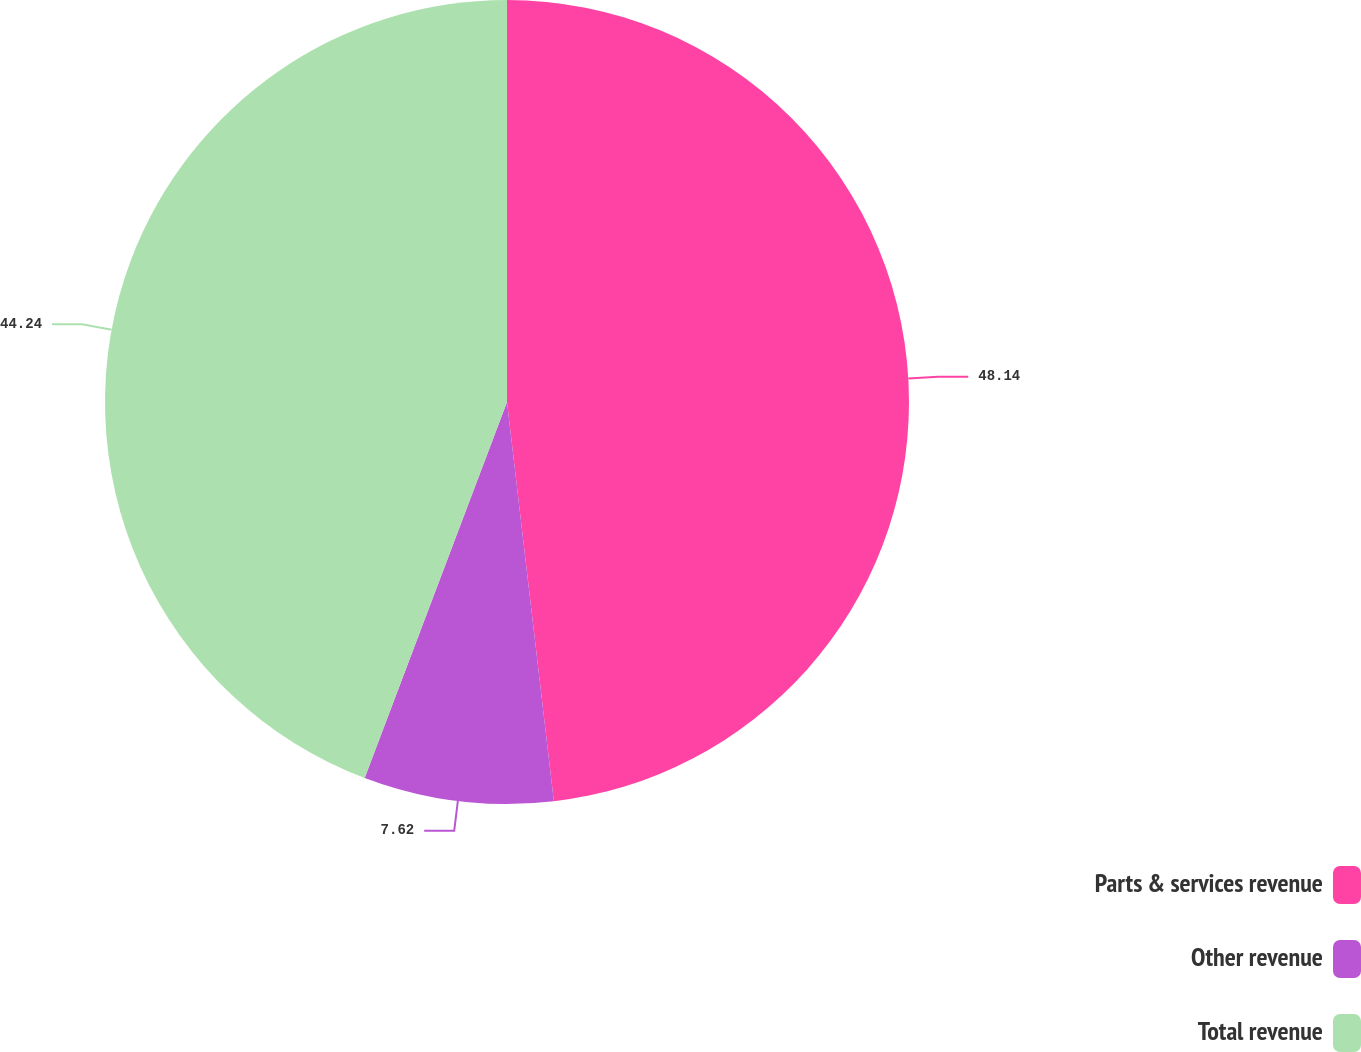Convert chart to OTSL. <chart><loc_0><loc_0><loc_500><loc_500><pie_chart><fcel>Parts & services revenue<fcel>Other revenue<fcel>Total revenue<nl><fcel>48.14%<fcel>7.62%<fcel>44.24%<nl></chart> 